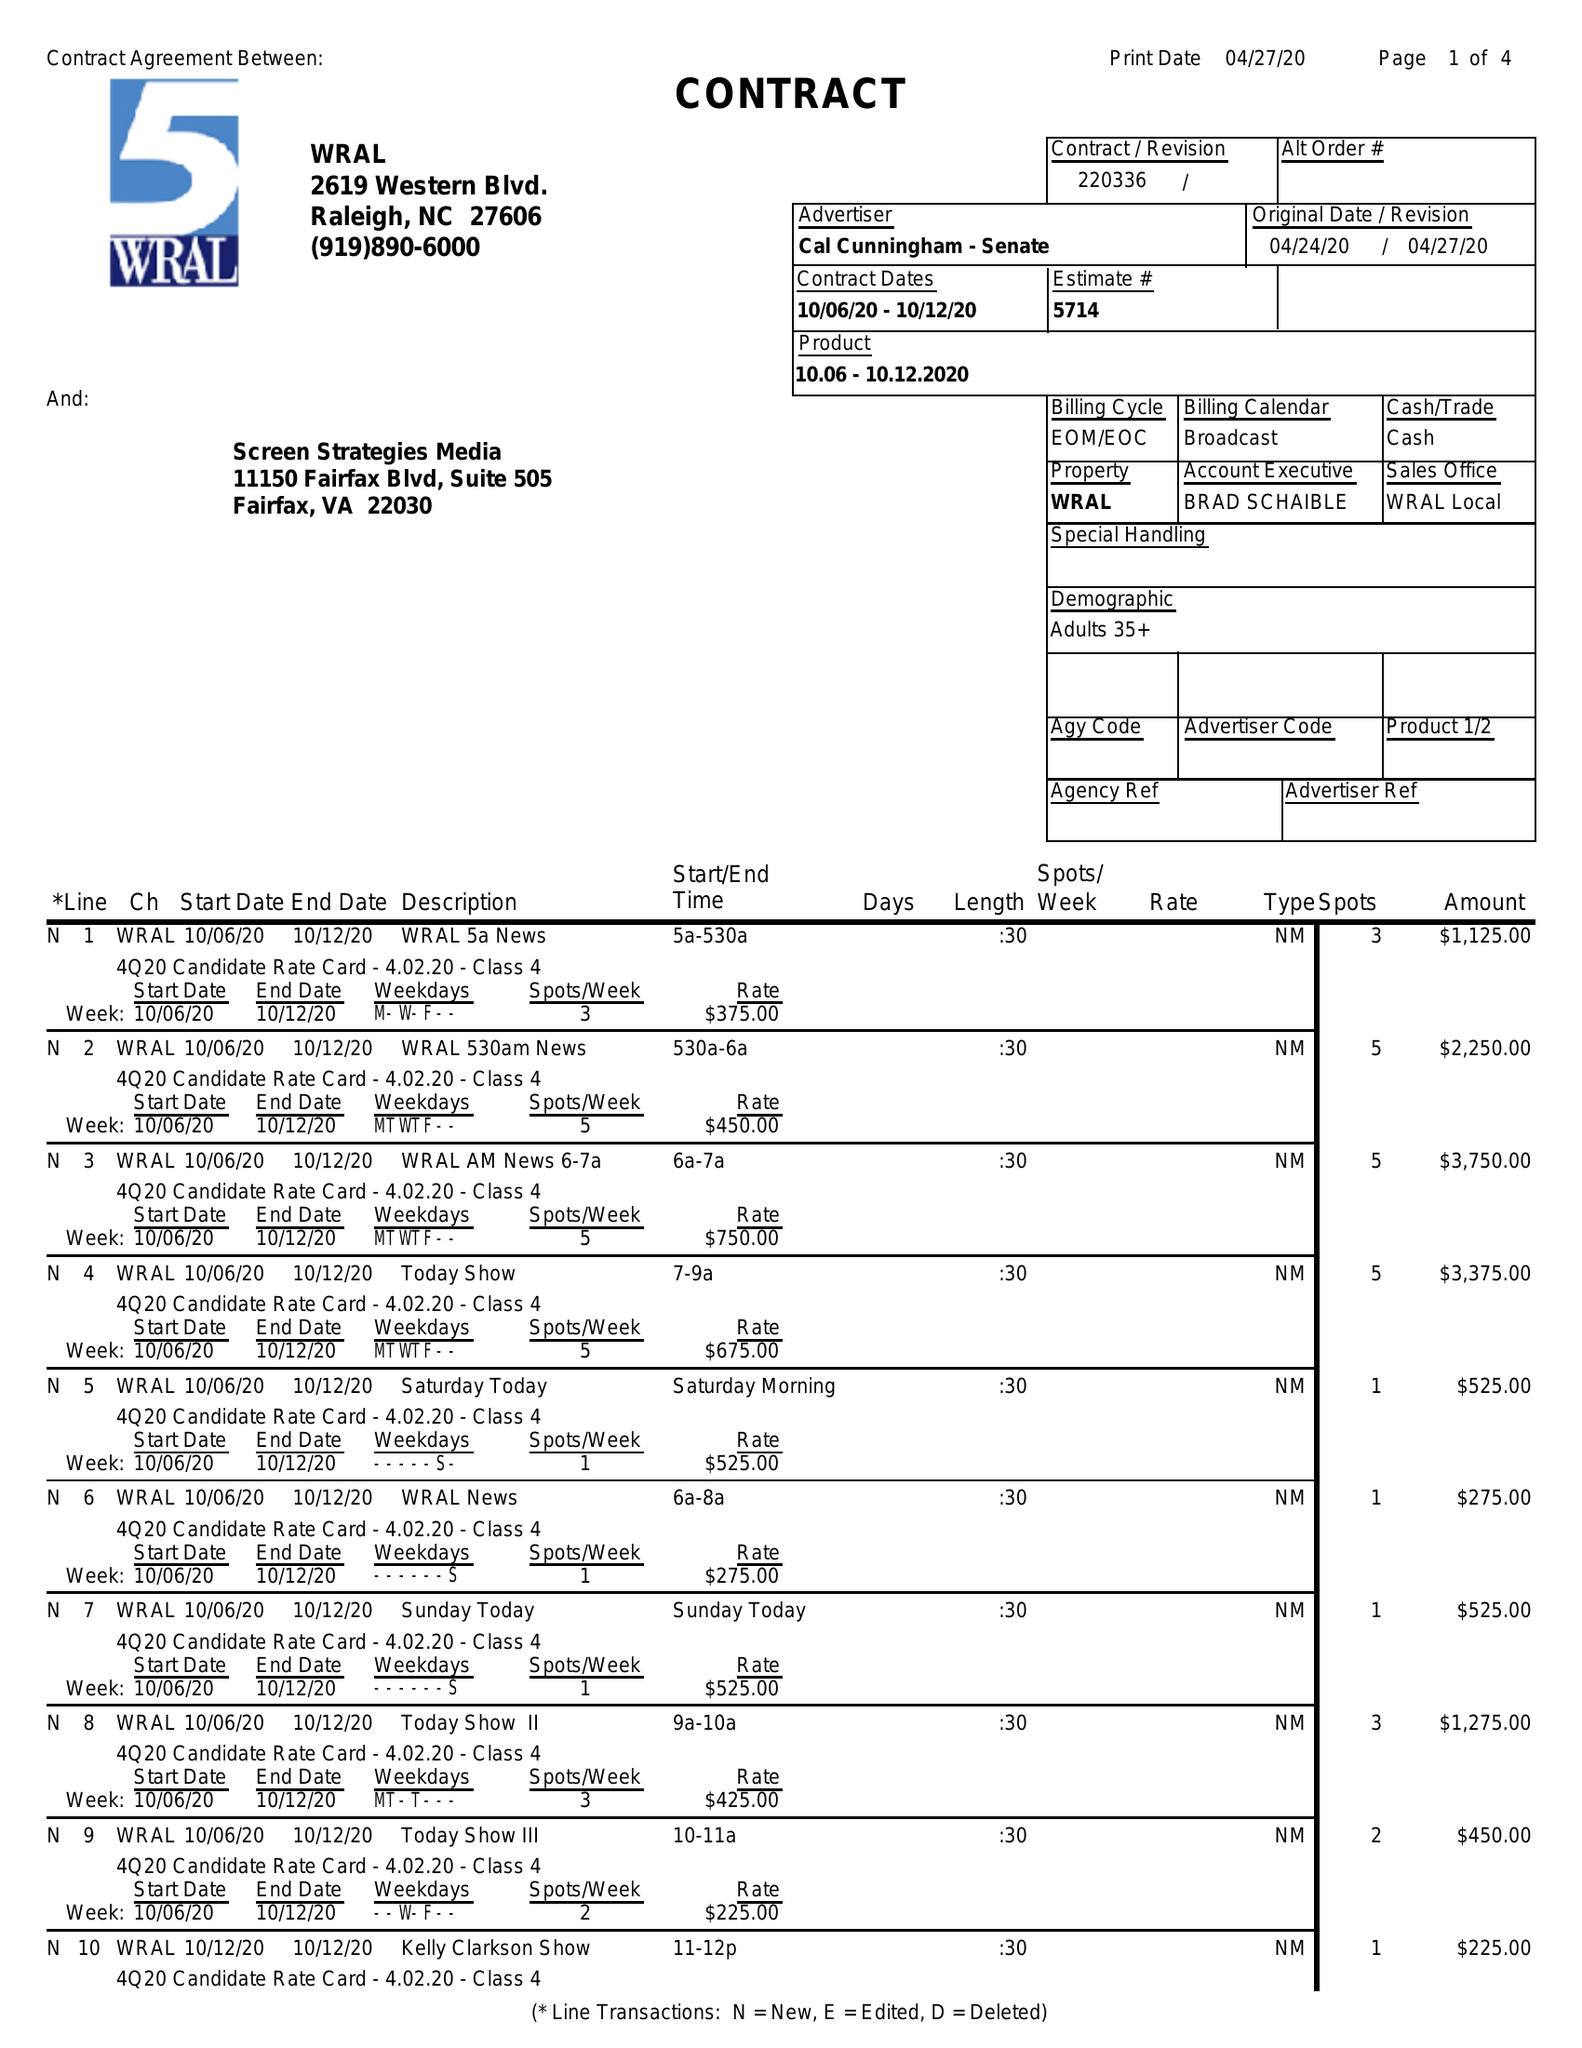What is the value for the contract_num?
Answer the question using a single word or phrase. 220336 